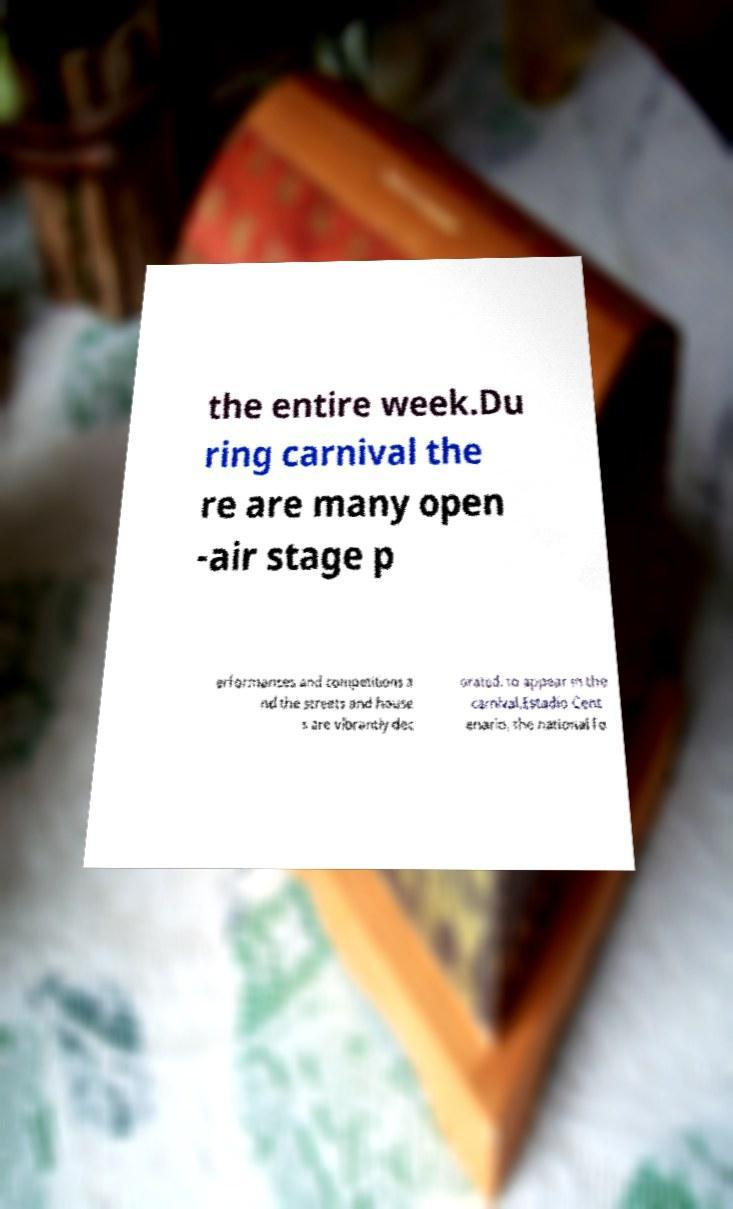Could you extract and type out the text from this image? the entire week.Du ring carnival the re are many open -air stage p erformances and competitions a nd the streets and house s are vibrantly dec orated. to appear in the carnival.Estadio Cent enario, the national fo 